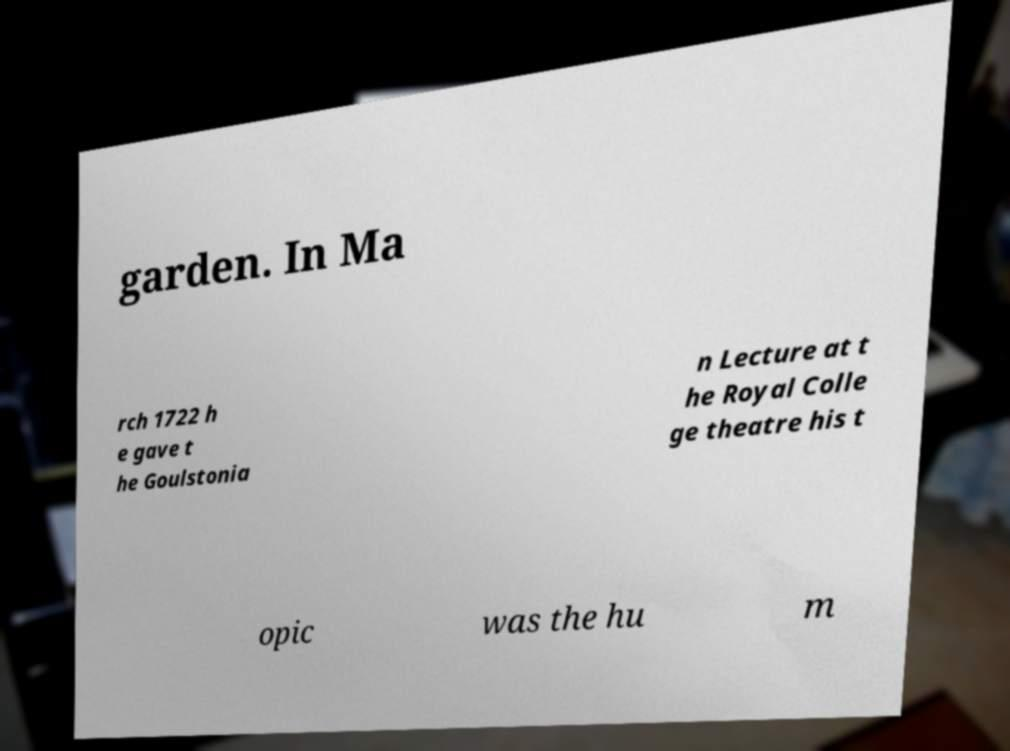There's text embedded in this image that I need extracted. Can you transcribe it verbatim? garden. In Ma rch 1722 h e gave t he Goulstonia n Lecture at t he Royal Colle ge theatre his t opic was the hu m 